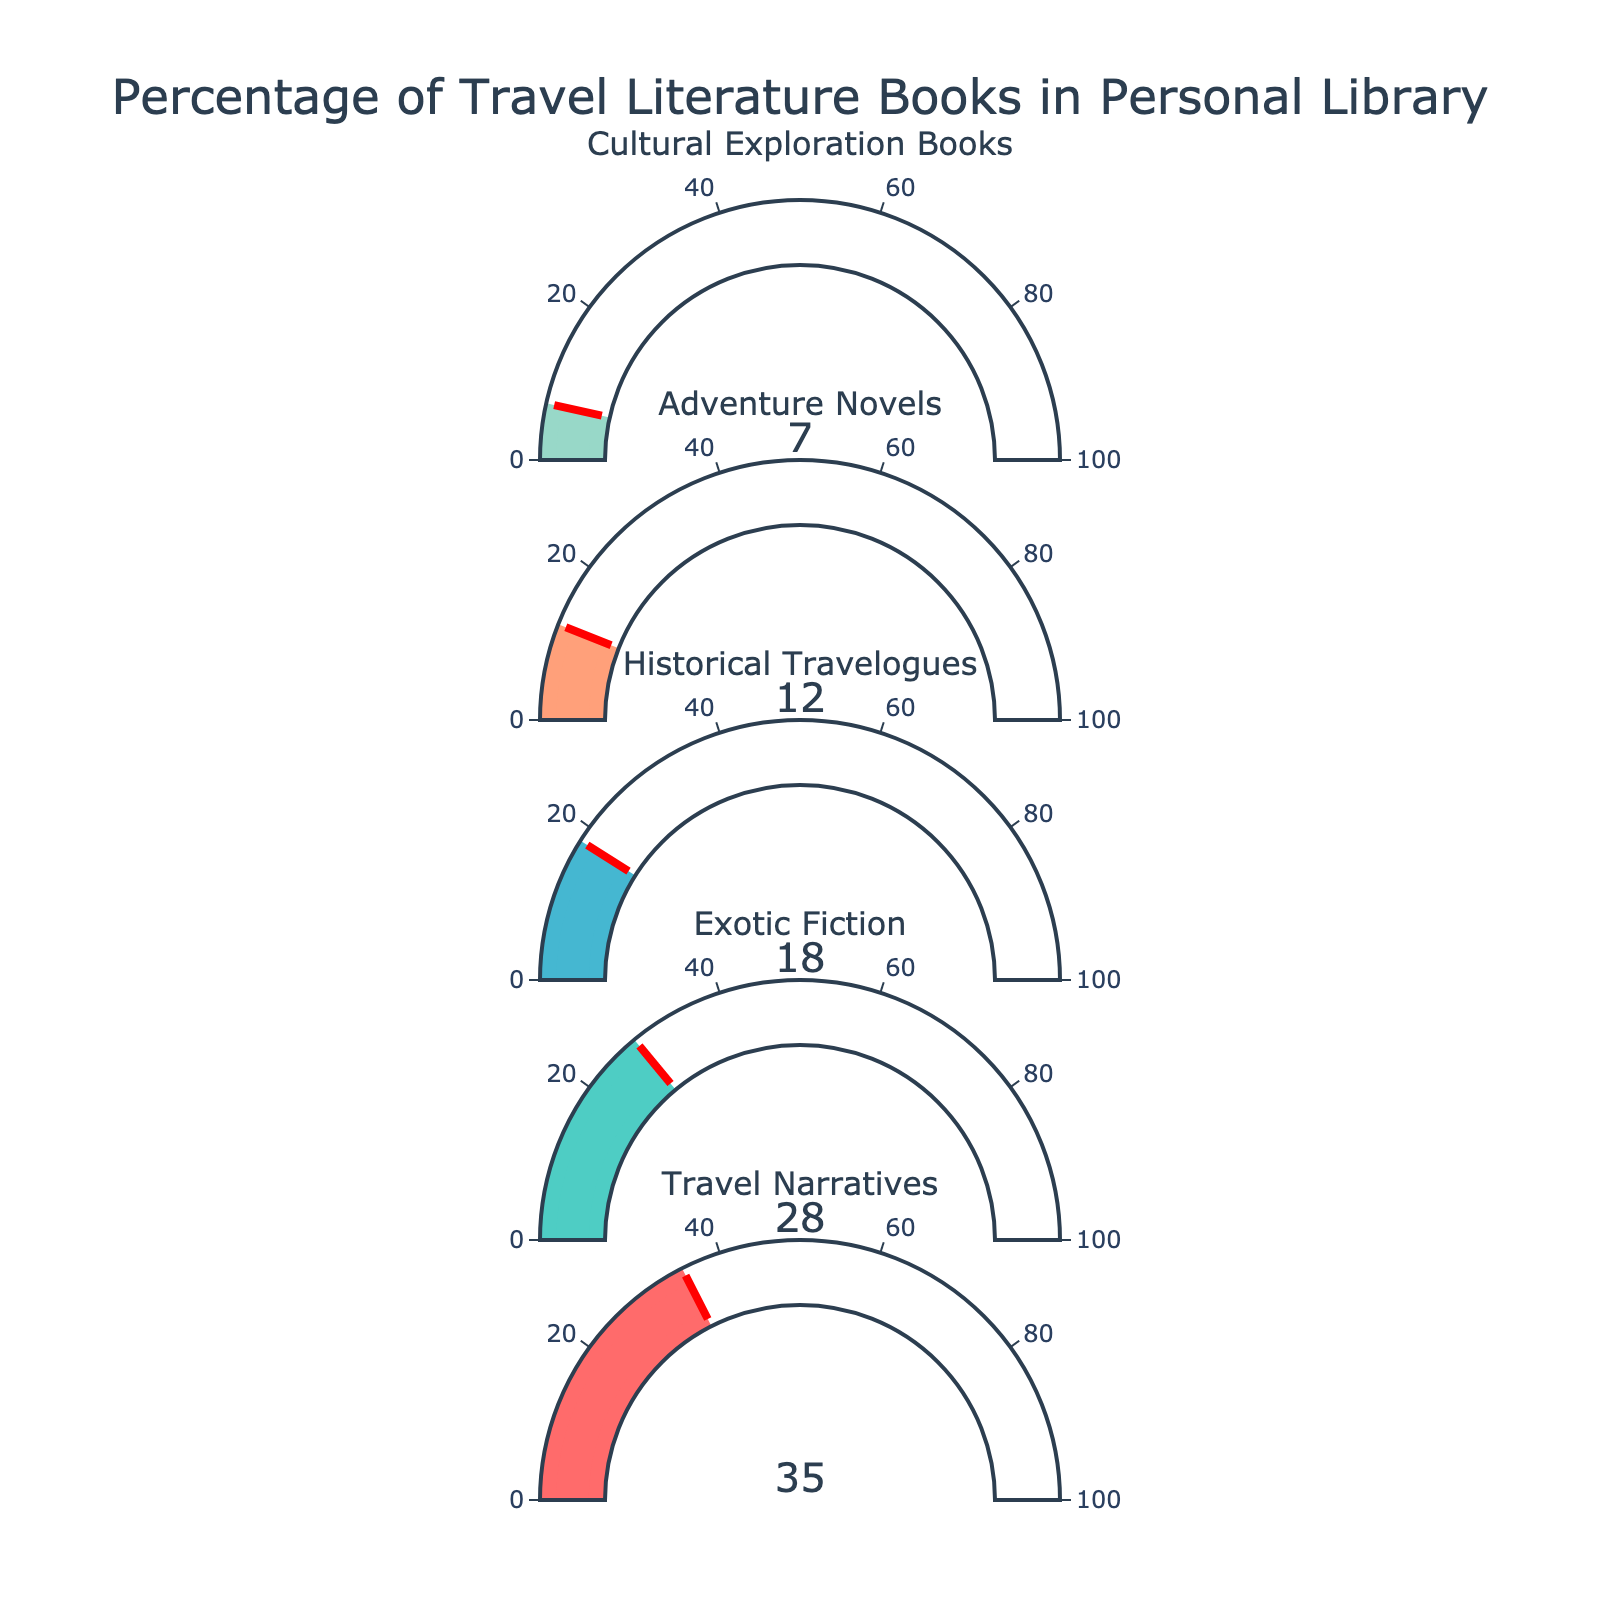What is the highest percentage category in the gauge chart? The highest percentage category corresponds to the category with the largest number on the gauge. According to the data, "Travel Narratives" has the highest percentage with 35%.
Answer: Travel Narratives What is the percentage of Exotic Fiction in the gauge chart? The percentage of Exotic Fiction is directly displayed on its gauge, showing 28%.
Answer: 28% How many categories have a percentage displayed in the figure? The number of categories corresponds to the number of gauges in the figure. There are 5 categories listed: Travel Narratives, Exotic Fiction, Historical Travelogues, Adventure Novels, and Cultural Exploration Books.
Answer: 5 What is the difference between the percentages of Travel Narratives and Historical Travelogues? The percentage of Travel Narratives is 35% and the percentage of Historical Travelogues is 18%. The difference is calculated as 35% - 18% = 17%.
Answer: 17% Which category has the lowest percentage in the gauge chart? The category with the lowest percentage is displayed as having the smallest number on its gauge. "Cultural Exploration Books" has the lowest percentage at 7%.
Answer: Cultural Exploration Books What is the sum of the percentages of Adventure Novels and Cultural Exploration Books? The percentage of Adventure Novels is 12% and the percentage of Cultural Exploration Books is 7%. Summing them up gives 12% + 7% = 19%.
Answer: 19% How much more percentage does the category with the highest percentage have compared to the category with the lowest percentage? The highest percentage is 35% (Travel Narratives) and the lowest percentage is 7% (Cultural Exploration Books). The difference is calculated as 35% - 7% = 28%.
Answer: 28% What is the combined percentage of categories that fall under fiction (Exotic Fiction and Adventure Novels)? The percentages of Exotic Fiction and Adventure Novels are 28% and 12% respectively. Summing them together gives 28% + 12% = 40%.
Answer: 40% Which category falls in the middle in terms of its percentage value? Arranging the percentages in ascending order (7%, 12%, 18%, 28%, 35%), Historical Travelogues (18%) falls in the middle.
Answer: Historical Travelogues How many categories have a percentage greater than 20%? Comparing the percentage values, the categories with percentages greater than 20% are Travel Narratives (35%) and Exotic Fiction (28%). That's a total of 2 categories.
Answer: 2 